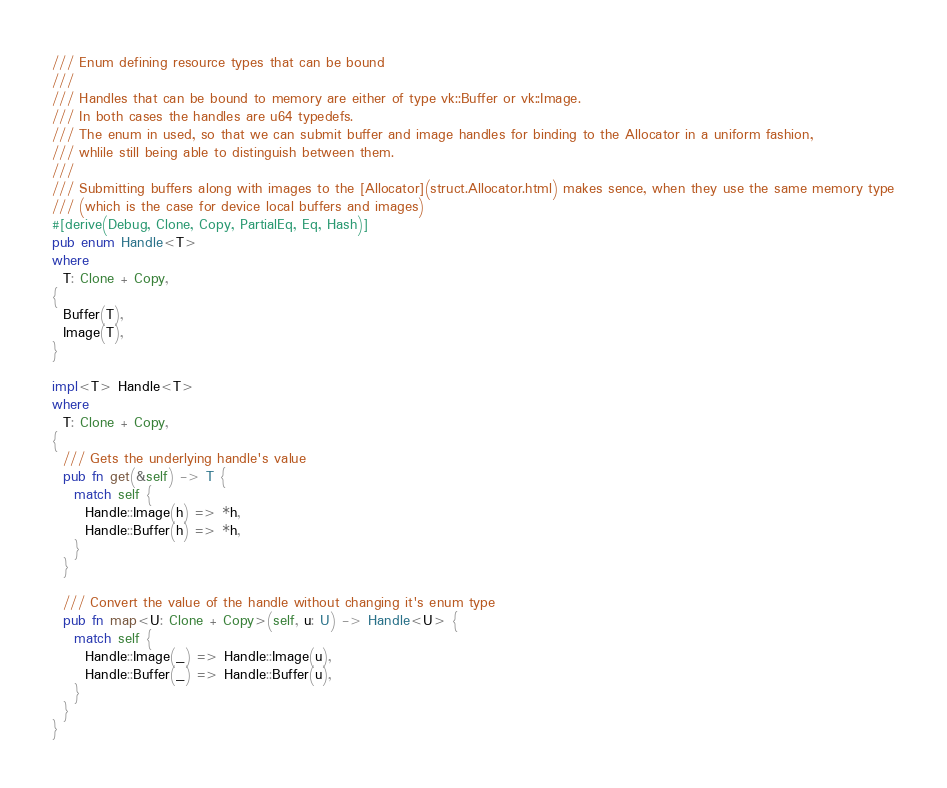Convert code to text. <code><loc_0><loc_0><loc_500><loc_500><_Rust_>
/// Enum defining resource types that can be bound
///
/// Handles that can be bound to memory are either of type vk::Buffer or vk::Image.
/// In both cases the handles are u64 typedefs.
/// The enum in used, so that we can submit buffer and image handles for binding to the Allocator in a uniform fashion,
/// whlile still being able to distinguish between them.
///
/// Submitting buffers along with images to the [Allocator](struct.Allocator.html) makes sence, when they use the same memory type
/// (which is the case for device local buffers and images)
#[derive(Debug, Clone, Copy, PartialEq, Eq, Hash)]
pub enum Handle<T>
where
  T: Clone + Copy,
{
  Buffer(T),
  Image(T),
}

impl<T> Handle<T>
where
  T: Clone + Copy,
{
  /// Gets the underlying handle's value
  pub fn get(&self) -> T {
    match self {
      Handle::Image(h) => *h,
      Handle::Buffer(h) => *h,
    }
  }

  /// Convert the value of the handle without changing it's enum type
  pub fn map<U: Clone + Copy>(self, u: U) -> Handle<U> {
    match self {
      Handle::Image(_) => Handle::Image(u),
      Handle::Buffer(_) => Handle::Buffer(u),
    }
  }
}

</code> 